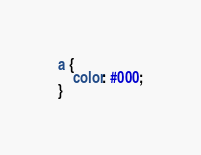<code> <loc_0><loc_0><loc_500><loc_500><_CSS_>a {
	color: #000;
}

</code> 